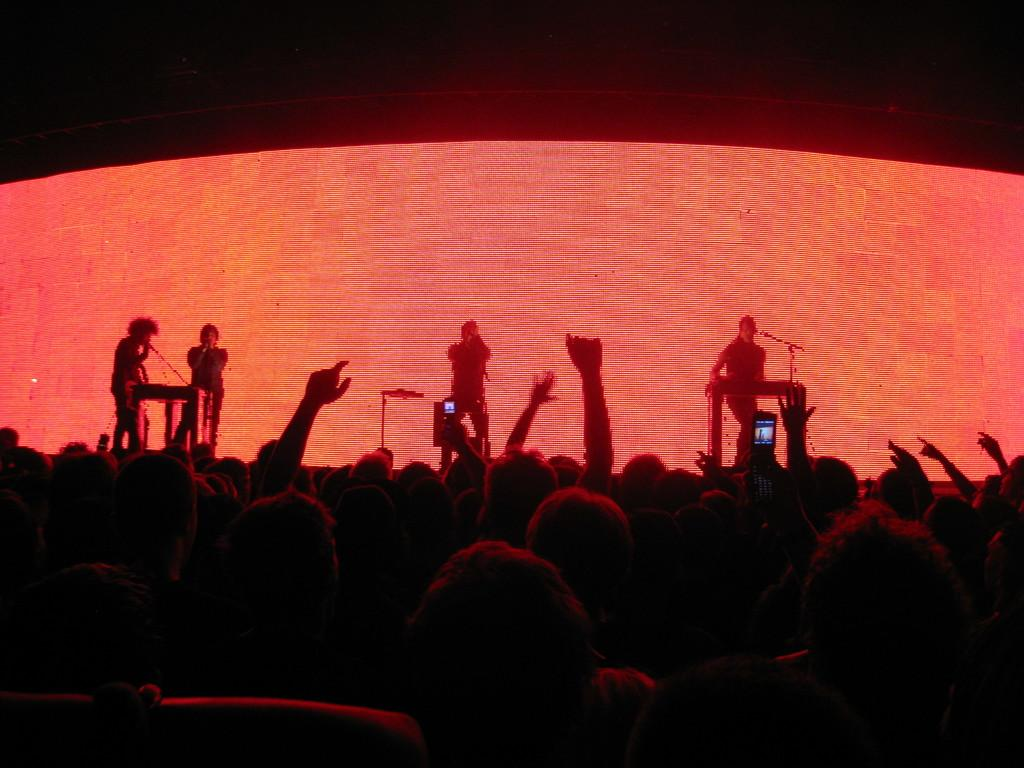What is the main subject of the image? The main subject of the image is a group of persons. What are the people in the background doing? The people in the background are holding mics. What color is the background of the image? The background of the image is red. What type of wax can be seen dripping from the mics in the image? There is no wax present in the image, nor is there any indication of wax dripping from the mics. 